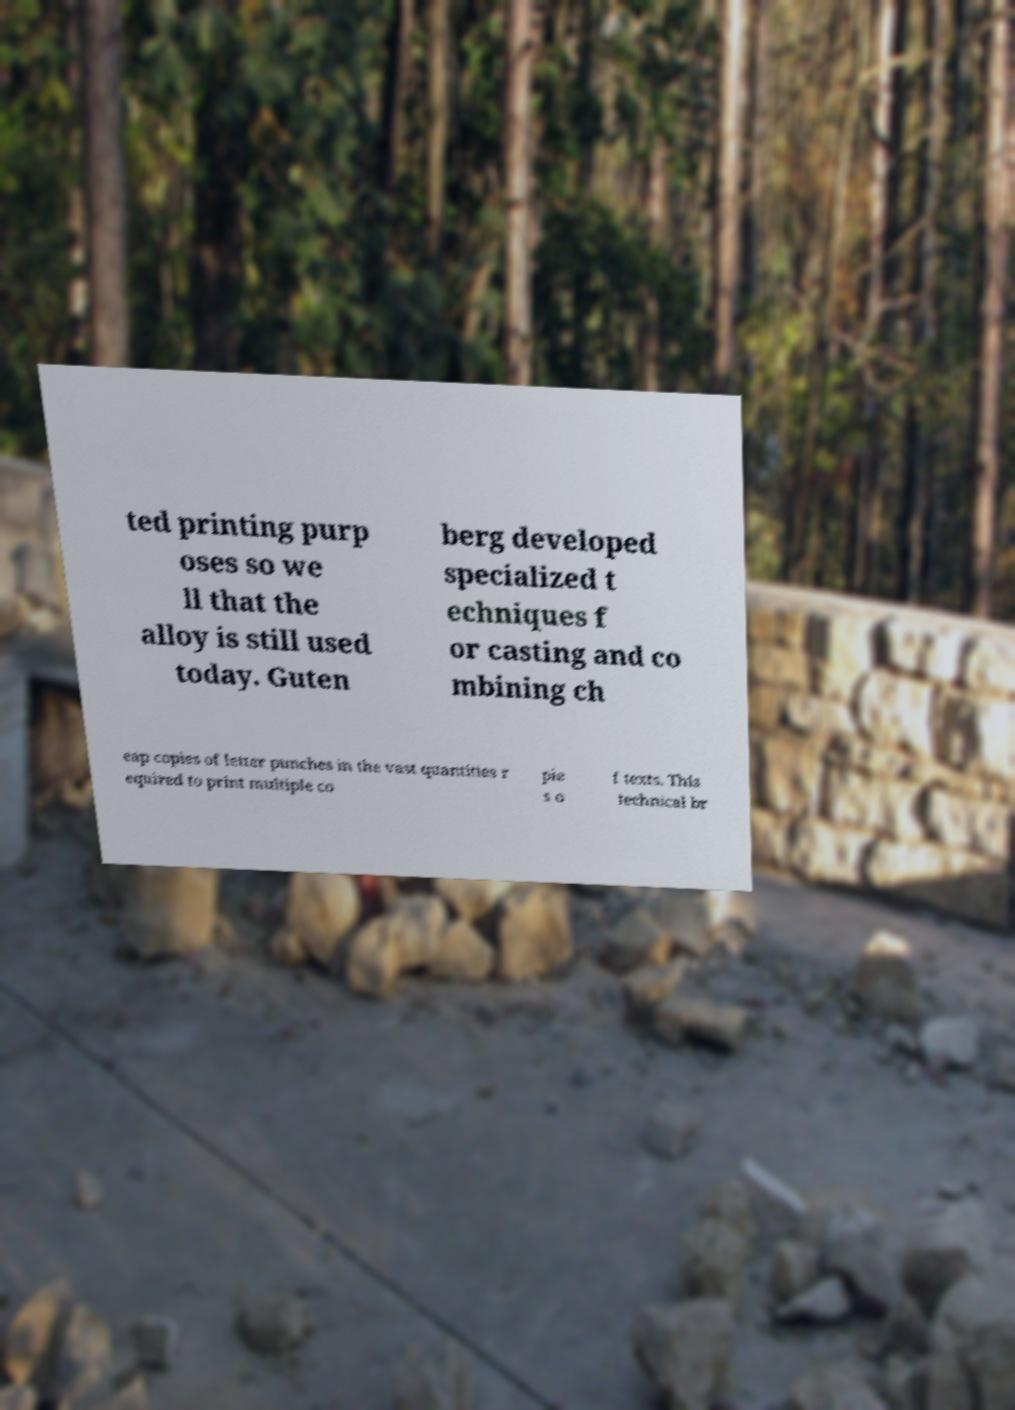There's text embedded in this image that I need extracted. Can you transcribe it verbatim? ted printing purp oses so we ll that the alloy is still used today. Guten berg developed specialized t echniques f or casting and co mbining ch eap copies of letter punches in the vast quantities r equired to print multiple co pie s o f texts. This technical br 